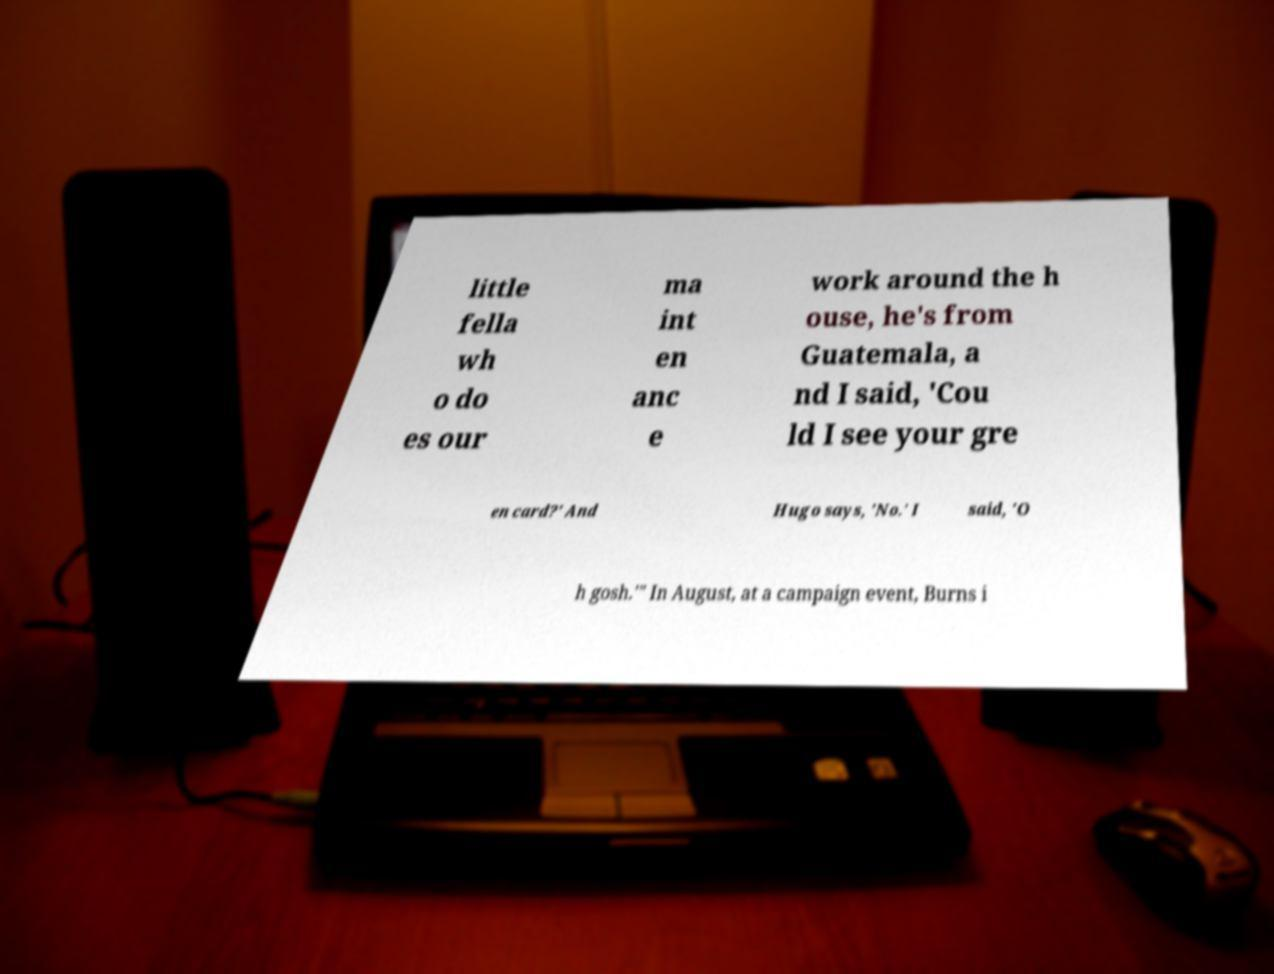Please identify and transcribe the text found in this image. little fella wh o do es our ma int en anc e work around the h ouse, he's from Guatemala, a nd I said, 'Cou ld I see your gre en card?' And Hugo says, 'No.' I said, 'O h gosh.'" In August, at a campaign event, Burns i 